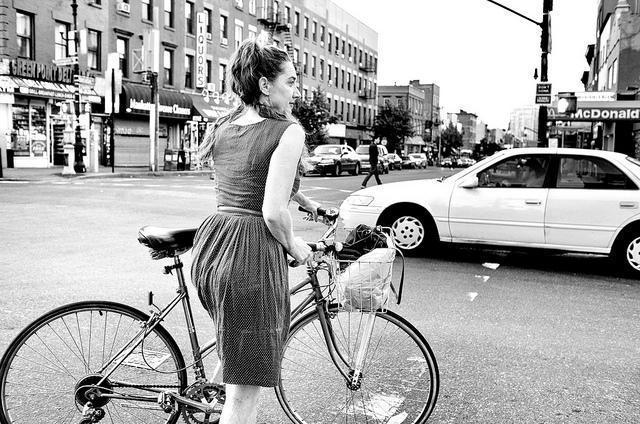How many yellow buses are in the picture?
Give a very brief answer. 0. 